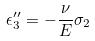Convert formula to latex. <formula><loc_0><loc_0><loc_500><loc_500>\epsilon _ { 3 } ^ { \prime \prime } = - \frac { \nu } { E } \sigma _ { 2 }</formula> 